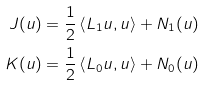Convert formula to latex. <formula><loc_0><loc_0><loc_500><loc_500>J ( u ) & = \frac { 1 } { 2 } \left \langle L _ { 1 } u , u \right \rangle + N _ { 1 } ( u ) \\ K ( u ) & = \frac { 1 } { 2 } \left \langle L _ { 0 } u , u \right \rangle + N _ { 0 } ( u )</formula> 